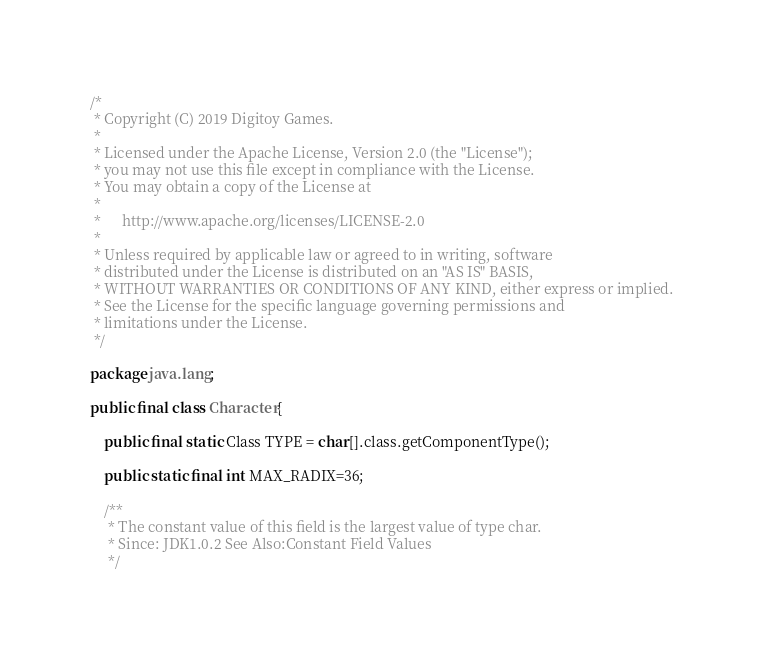Convert code to text. <code><loc_0><loc_0><loc_500><loc_500><_Java_>/*
 * Copyright (C) 2019 Digitoy Games.
 *
 * Licensed under the Apache License, Version 2.0 (the "License");
 * you may not use this file except in compliance with the License.
 * You may obtain a copy of the License at
 *
 *      http://www.apache.org/licenses/LICENSE-2.0
 *
 * Unless required by applicable law or agreed to in writing, software
 * distributed under the License is distributed on an "AS IS" BASIS,
 * WITHOUT WARRANTIES OR CONDITIONS OF ANY KIND, either express or implied.
 * See the License for the specific language governing permissions and
 * limitations under the License.
 */

package java.lang;

public final class Character{
    
    public final static Class TYPE = char[].class.getComponentType();
    
    public static final int MAX_RADIX=36;

    /**
     * The constant value of this field is the largest value of type char.
     * Since: JDK1.0.2 See Also:Constant Field Values
     */</code> 